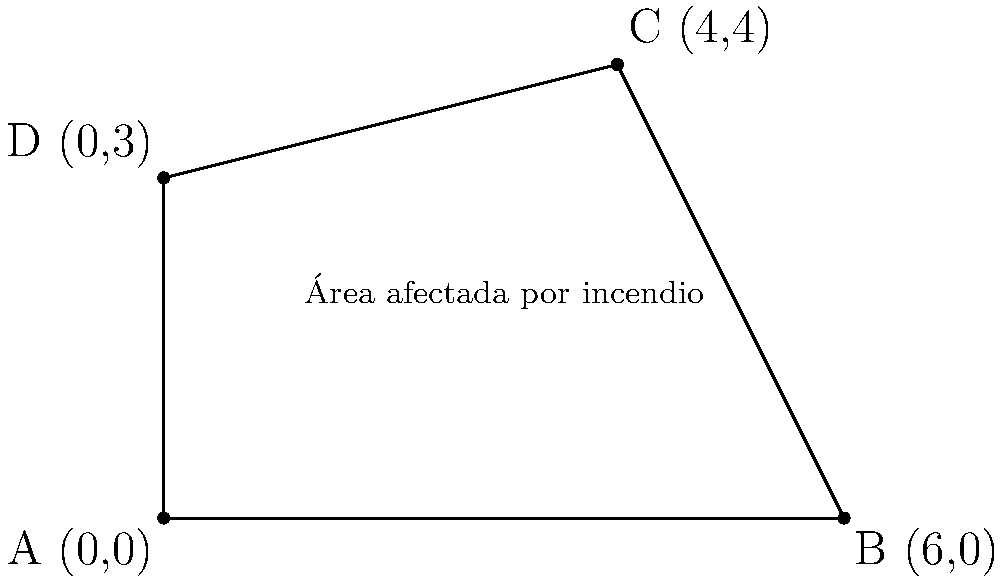Un incendio forestal ha afectado una región en forma de cuadrilátero en el Bosque de Chapultepec. Los satélites de monitoreo ambiental han proporcionado las coordenadas de los vértices del área afectada: A(0,0), B(6,0), C(4,4), y D(0,3). Calcula el área total afectada por el incendio en kilómetros cuadrados, considerando que cada unidad en el plano cartesiano representa 1 km. Para calcular el área del cuadrilátero irregular, podemos dividirlo en dos triángulos y sumar sus áreas:

1. Dividimos el cuadrilátero ABCD en dos triángulos: ABC y ACD.

2. Para el triángulo ABC:
   Base = 6 km (distancia entre A y B)
   Altura = 4 km (altura de C)
   Área_ABC = $\frac{1}{2} \times 6 \times 4 = 12$ km²

3. Para el triángulo ACD:
   Usamos la fórmula del área de un triángulo con coordenadas:
   Área = $\frac{1}{2}|x_1(y_2 - y_3) + x_2(y_3 - y_1) + x_3(y_1 - y_2)|$
   Donde (x₁,y₁) = (0,0), (x₂,y₂) = (4,4), (x₃,y₃) = (0,3)

   Área_ACD = $\frac{1}{2}|0(4 - 3) + 4(3 - 0) + 0(0 - 4)|$
             = $\frac{1}{2}|0 + 12 + 0|$
             = $\frac{1}{2} \times 12 = 6$ km²

4. Área total = Área_ABC + Área_ACD
              = 12 + 6 = 18 km²

Por lo tanto, el área total afectada por el incendio es de 18 km².
Answer: 18 km² 